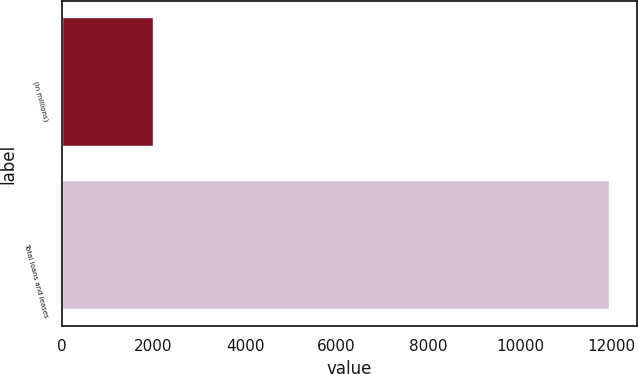<chart> <loc_0><loc_0><loc_500><loc_500><bar_chart><fcel>(In millions)<fcel>Total loans and leases<nl><fcel>2010<fcel>11957<nl></chart> 